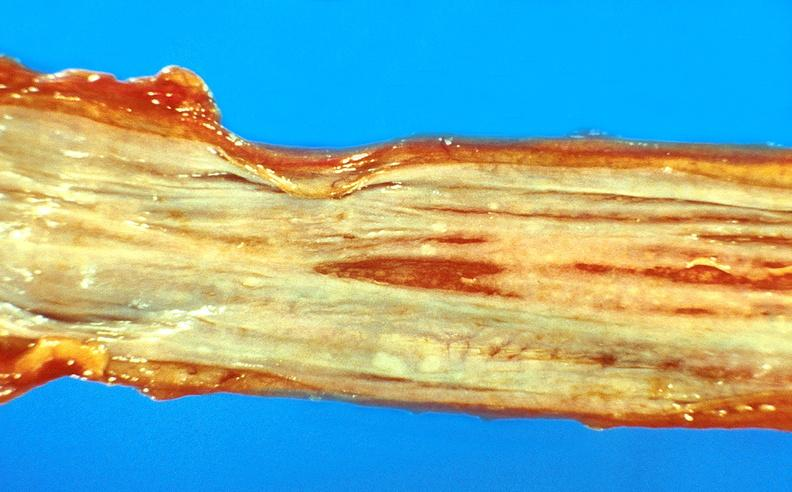where does this belong to?
Answer the question using a single word or phrase. Gastrointestinal system 